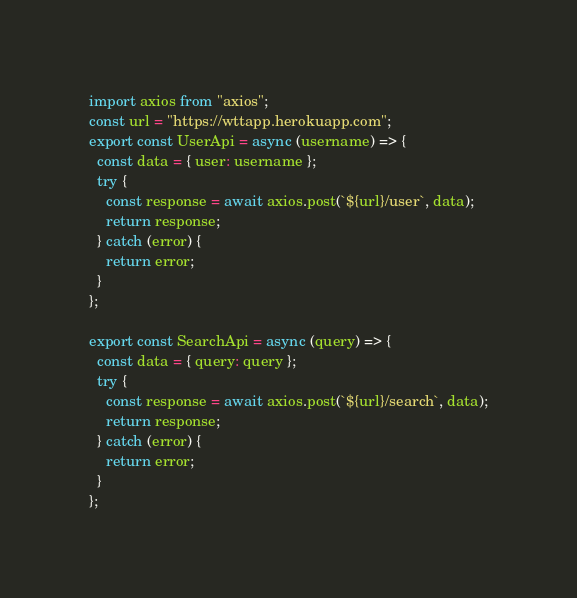<code> <loc_0><loc_0><loc_500><loc_500><_JavaScript_>import axios from "axios";
const url = "https://wttapp.herokuapp.com";
export const UserApi = async (username) => {
  const data = { user: username };
  try {
    const response = await axios.post(`${url}/user`, data);
    return response;
  } catch (error) {
    return error;
  }
};

export const SearchApi = async (query) => {
  const data = { query: query };
  try {
    const response = await axios.post(`${url}/search`, data);
    return response;
  } catch (error) {
    return error;
  }
};
</code> 